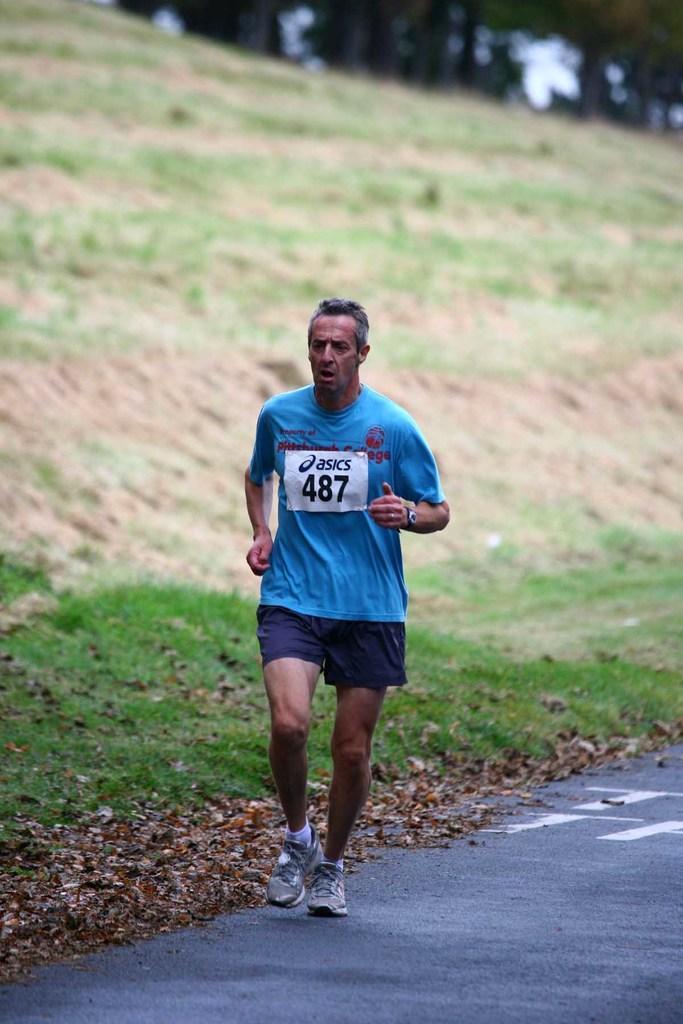How would you summarize this image in a sentence or two? This is the man running on the road. I can see the dried leaves lying on the ground. Here is the grass. This looks like a hill. The background looks blurry. 